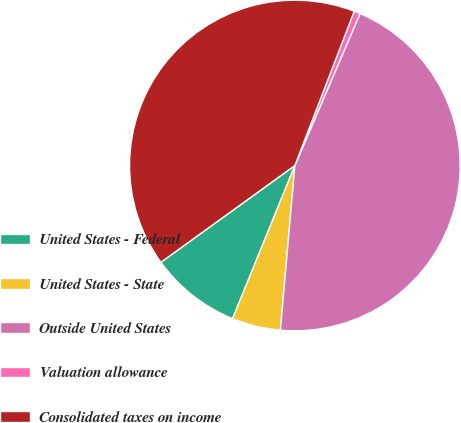Convert chart. <chart><loc_0><loc_0><loc_500><loc_500><pie_chart><fcel>United States - Federal<fcel>United States - State<fcel>Outside United States<fcel>Valuation allowance<fcel>Consolidated taxes on income<nl><fcel>8.89%<fcel>4.75%<fcel>44.95%<fcel>0.6%<fcel>40.8%<nl></chart> 